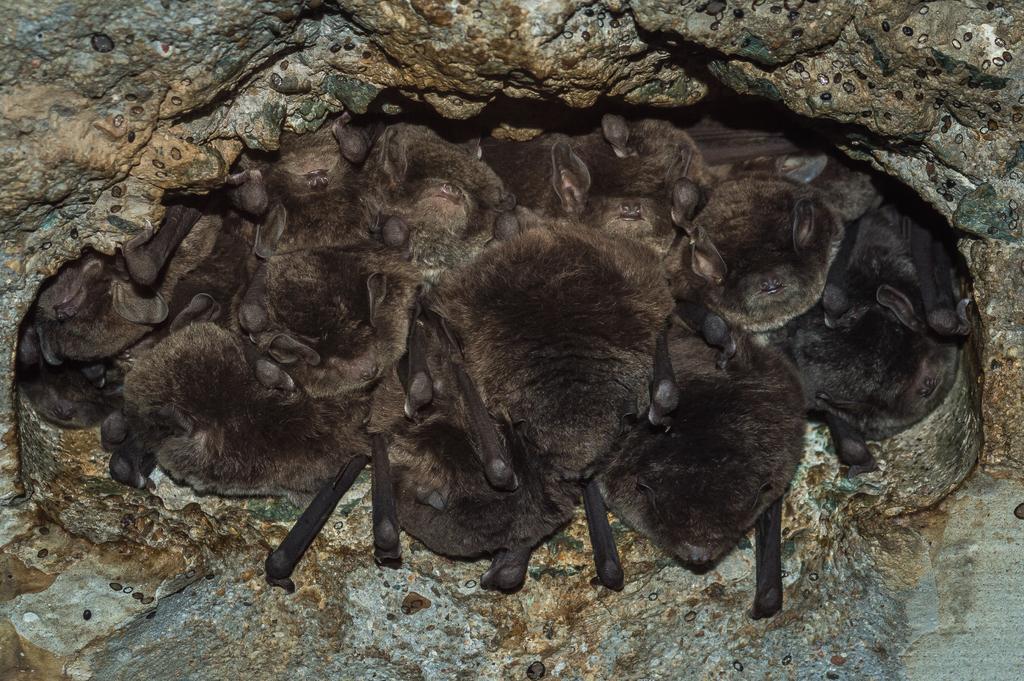Could you give a brief overview of what you see in this image? This image consists of bats. They are in black color. In the background, we can see a rock. 